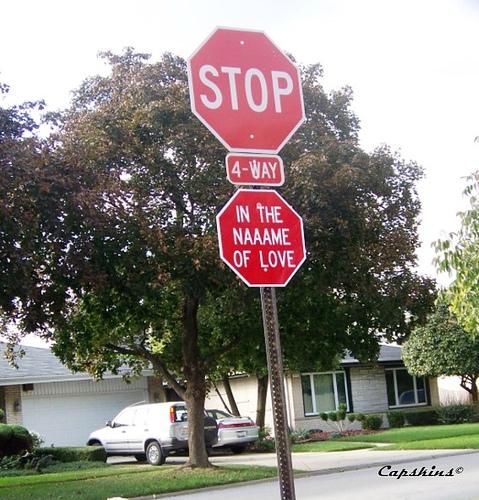What is on the stop sign?
Answer briefly. In name of love. What word is spelled incorrectly?
Concise answer only. Name. What song is the sign referencing?
Write a very short answer. Stop in name of love. What does the sign below the stop say?
Concise answer only. In name of love. Are cars allowed in this area?
Be succinct. Yes. Is the bottom sign an officially recognized street sign?
Quick response, please. No. 